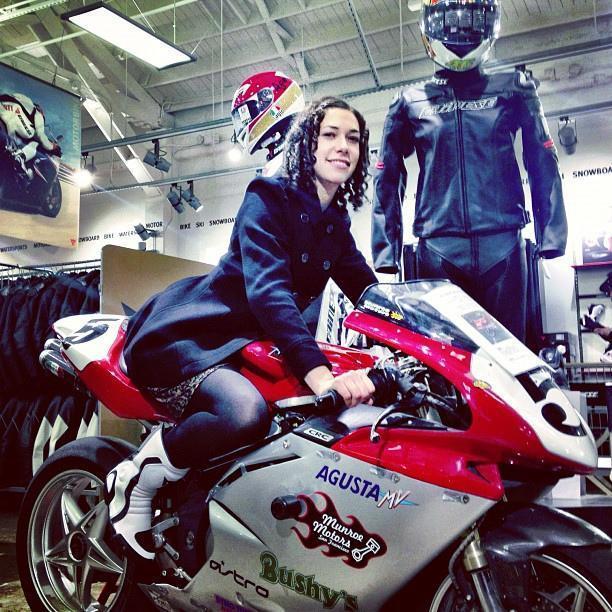How many people are in this photo?
Give a very brief answer. 1. How many people are there?
Give a very brief answer. 2. 